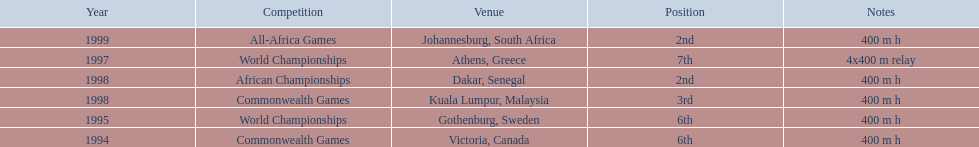What races did ken harden run? 400 m h, 400 m h, 4x400 m relay, 400 m h, 400 m h, 400 m h. Which race did ken harden run in 1997? 4x400 m relay. 